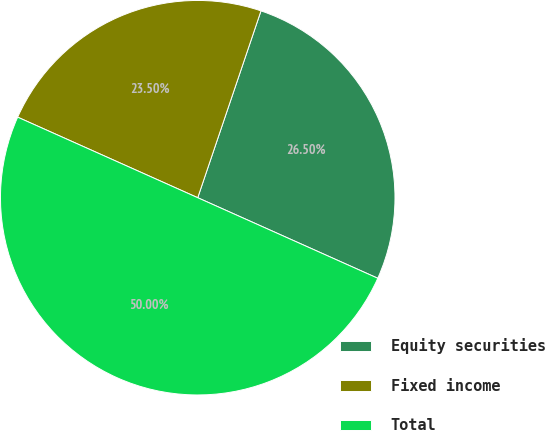Convert chart. <chart><loc_0><loc_0><loc_500><loc_500><pie_chart><fcel>Equity securities<fcel>Fixed income<fcel>Total<nl><fcel>26.5%<fcel>23.5%<fcel>50.0%<nl></chart> 